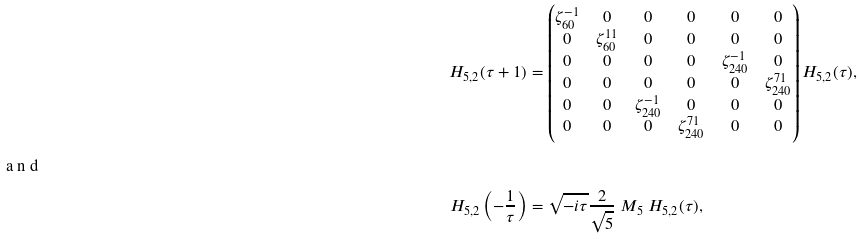<formula> <loc_0><loc_0><loc_500><loc_500>H _ { 5 , 2 } ( \tau + 1 ) & = \begin{pmatrix} \zeta _ { 6 0 } ^ { - 1 } & 0 & 0 & 0 & 0 & 0 \\ 0 & \zeta _ { 6 0 } ^ { 1 1 } & 0 & 0 & 0 & 0 \\ 0 & 0 & 0 & 0 & \zeta _ { 2 4 0 } ^ { - 1 } & 0 \\ 0 & 0 & 0 & 0 & 0 & \zeta _ { 2 4 0 } ^ { 7 1 } \\ 0 & 0 & \zeta _ { 2 4 0 } ^ { - 1 } & 0 & 0 & 0 \\ 0 & 0 & 0 & \zeta _ { 2 4 0 } ^ { 7 1 } & 0 & 0 \end{pmatrix} H _ { 5 , 2 } ( \tau ) , \\ \intertext { a n d } H _ { 5 , 2 } \left ( - \frac { 1 } { \tau } \right ) & = \sqrt { - i \tau } \frac { 2 } { \sqrt { 5 } } \ M _ { 5 } \ H _ { 5 , 2 } ( \tau ) ,</formula> 